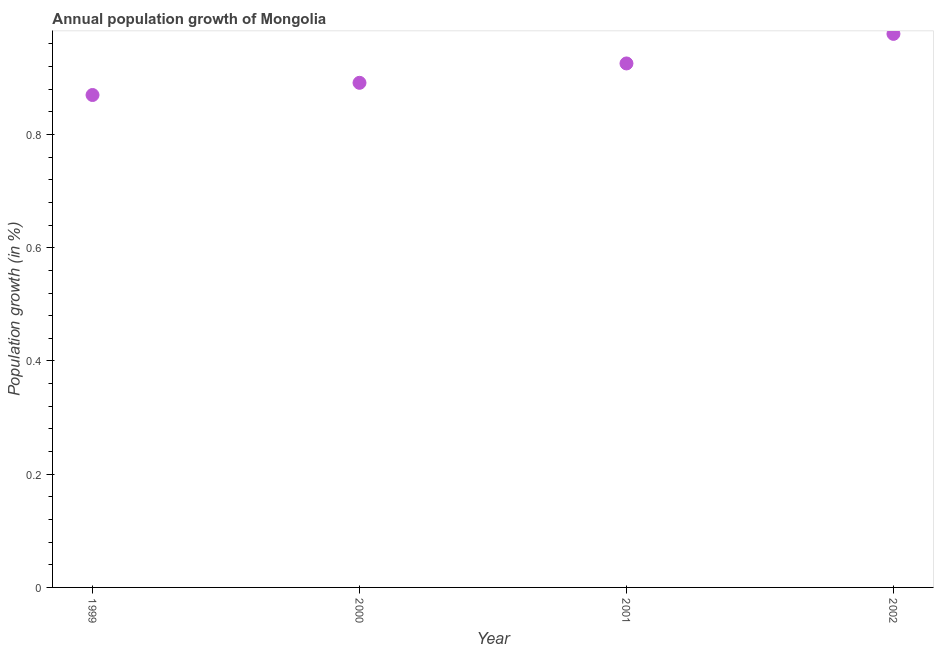What is the population growth in 2000?
Offer a terse response. 0.89. Across all years, what is the maximum population growth?
Your answer should be compact. 0.98. Across all years, what is the minimum population growth?
Ensure brevity in your answer.  0.87. What is the sum of the population growth?
Provide a short and direct response. 3.66. What is the difference between the population growth in 1999 and 2000?
Provide a succinct answer. -0.02. What is the average population growth per year?
Offer a terse response. 0.92. What is the median population growth?
Give a very brief answer. 0.91. Do a majority of the years between 2001 and 2000 (inclusive) have population growth greater than 0.32 %?
Provide a short and direct response. No. What is the ratio of the population growth in 1999 to that in 2002?
Ensure brevity in your answer.  0.89. What is the difference between the highest and the second highest population growth?
Your answer should be compact. 0.05. What is the difference between the highest and the lowest population growth?
Your answer should be compact. 0.11. In how many years, is the population growth greater than the average population growth taken over all years?
Ensure brevity in your answer.  2. Does the population growth monotonically increase over the years?
Your answer should be very brief. Yes. How many dotlines are there?
Give a very brief answer. 1. What is the title of the graph?
Your answer should be very brief. Annual population growth of Mongolia. What is the label or title of the X-axis?
Your response must be concise. Year. What is the label or title of the Y-axis?
Ensure brevity in your answer.  Population growth (in %). What is the Population growth (in %) in 1999?
Give a very brief answer. 0.87. What is the Population growth (in %) in 2000?
Give a very brief answer. 0.89. What is the Population growth (in %) in 2001?
Provide a succinct answer. 0.93. What is the Population growth (in %) in 2002?
Your response must be concise. 0.98. What is the difference between the Population growth (in %) in 1999 and 2000?
Offer a very short reply. -0.02. What is the difference between the Population growth (in %) in 1999 and 2001?
Your answer should be very brief. -0.06. What is the difference between the Population growth (in %) in 1999 and 2002?
Provide a succinct answer. -0.11. What is the difference between the Population growth (in %) in 2000 and 2001?
Provide a succinct answer. -0.03. What is the difference between the Population growth (in %) in 2000 and 2002?
Provide a succinct answer. -0.09. What is the difference between the Population growth (in %) in 2001 and 2002?
Give a very brief answer. -0.05. What is the ratio of the Population growth (in %) in 1999 to that in 2001?
Keep it short and to the point. 0.94. What is the ratio of the Population growth (in %) in 1999 to that in 2002?
Offer a terse response. 0.89. What is the ratio of the Population growth (in %) in 2000 to that in 2002?
Offer a terse response. 0.91. What is the ratio of the Population growth (in %) in 2001 to that in 2002?
Provide a succinct answer. 0.95. 